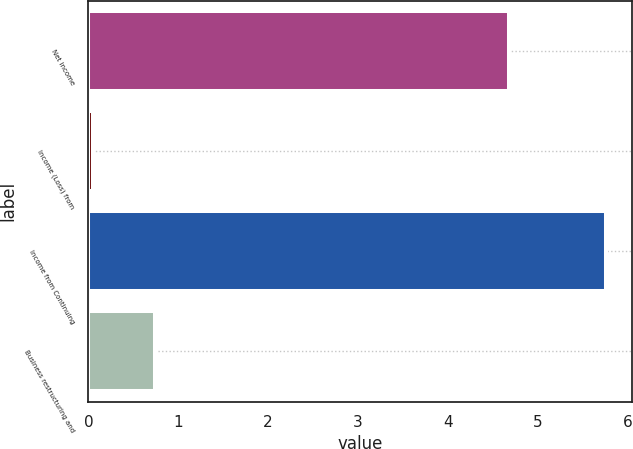Convert chart. <chart><loc_0><loc_0><loc_500><loc_500><bar_chart><fcel>Net income<fcel>Income (Loss) from<fcel>Income from Continuing<fcel>Business restructuring and<nl><fcel>4.68<fcel>0.05<fcel>5.76<fcel>0.74<nl></chart> 